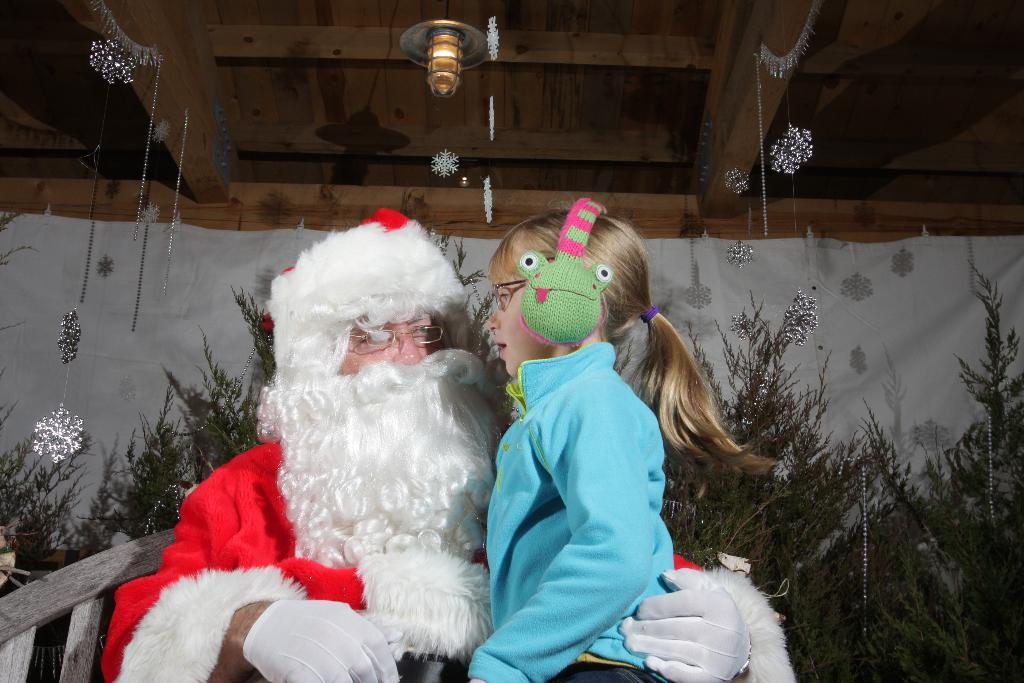Who is the main subject in the center of the image? There is a Santa Claus in the center of the image. What is the girl in the image doing? The girl is wearing a headset in the image. What can be seen in the background of the image? There are trees, a curtain, decorations, and lights visible in the background of the image. How does the girl pull the mist in the image? There is no mist present in the image, and therefore no such action can be observed. 